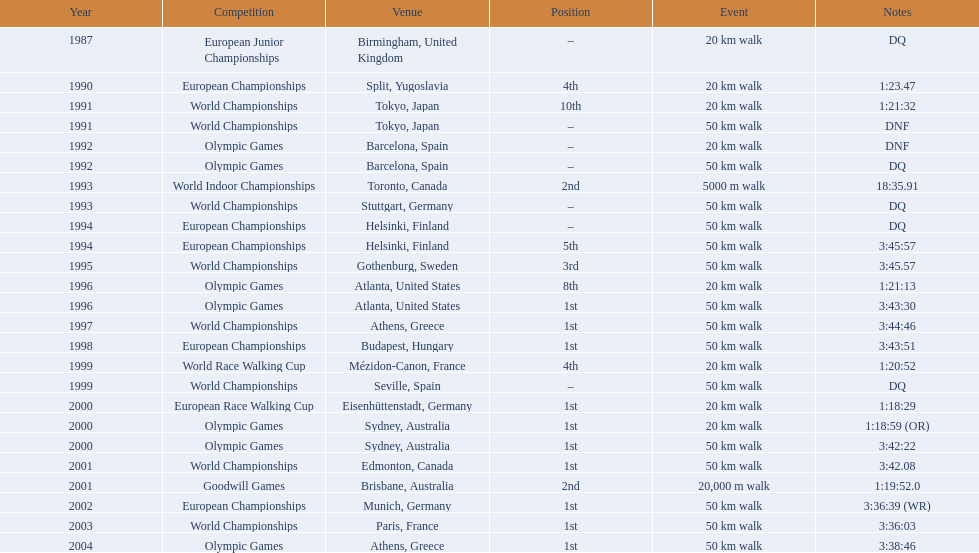Which of the tournaments featured 50 km walks? World Championships, Olympic Games, World Championships, European Championships, European Championships, World Championships, Olympic Games, World Championships, European Championships, World Championships, Olympic Games, World Championships, European Championships, World Championships, Olympic Games. Out of these, which transpired in or subsequent to the year 2000? Olympic Games, World Championships, European Championships, World Championships, Olympic Games. From this selection, which unfolded in athens, greece? Olympic Games. What was the time required to complete this specific competition? 3:38:46. 